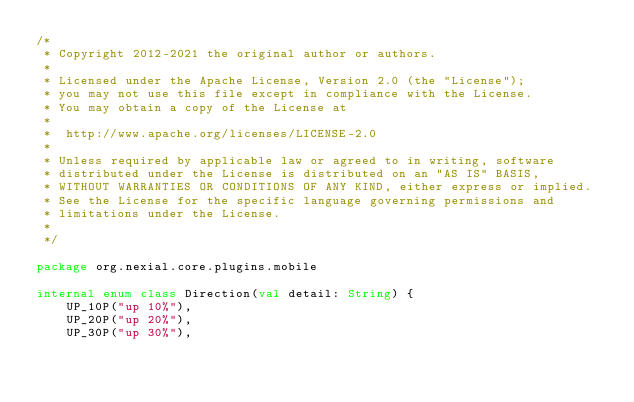Convert code to text. <code><loc_0><loc_0><loc_500><loc_500><_Kotlin_>/*
 * Copyright 2012-2021 the original author or authors.
 *
 * Licensed under the Apache License, Version 2.0 (the "License");
 * you may not use this file except in compliance with the License.
 * You may obtain a copy of the License at
 *
 * 	http://www.apache.org/licenses/LICENSE-2.0
 *
 * Unless required by applicable law or agreed to in writing, software
 * distributed under the License is distributed on an "AS IS" BASIS,
 * WITHOUT WARRANTIES OR CONDITIONS OF ANY KIND, either express or implied.
 * See the License for the specific language governing permissions and
 * limitations under the License.
 *
 */

package org.nexial.core.plugins.mobile

internal enum class Direction(val detail: String) {
    UP_10P("up 10%"),
    UP_20P("up 20%"),
    UP_30P("up 30%"),</code> 